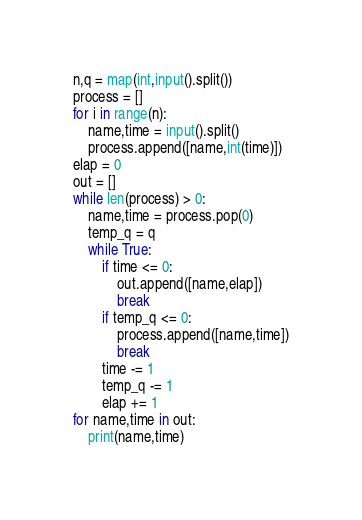<code> <loc_0><loc_0><loc_500><loc_500><_Python_>n,q = map(int,input().split())
process = []
for i in range(n):
    name,time = input().split()
    process.append([name,int(time)])
elap = 0
out = []
while len(process) > 0:
    name,time = process.pop(0)
    temp_q = q
    while True:
        if time <= 0:
            out.append([name,elap])
            break
        if temp_q <= 0:
            process.append([name,time])
            break
        time -= 1
        temp_q -= 1
        elap += 1
for name,time in out:
    print(name,time)
</code> 